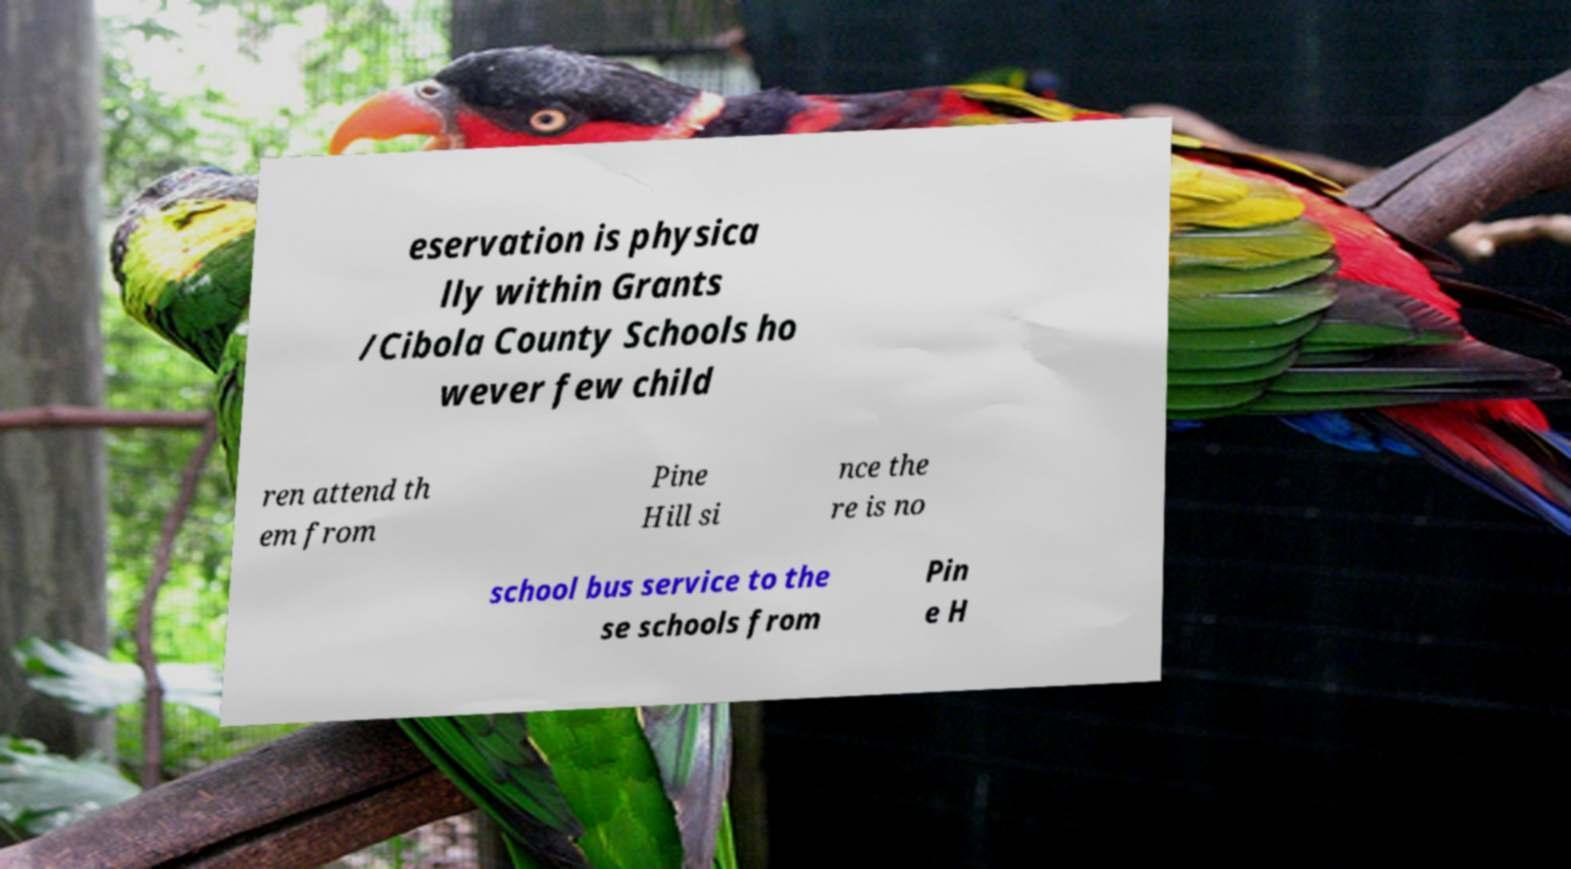I need the written content from this picture converted into text. Can you do that? eservation is physica lly within Grants /Cibola County Schools ho wever few child ren attend th em from Pine Hill si nce the re is no school bus service to the se schools from Pin e H 